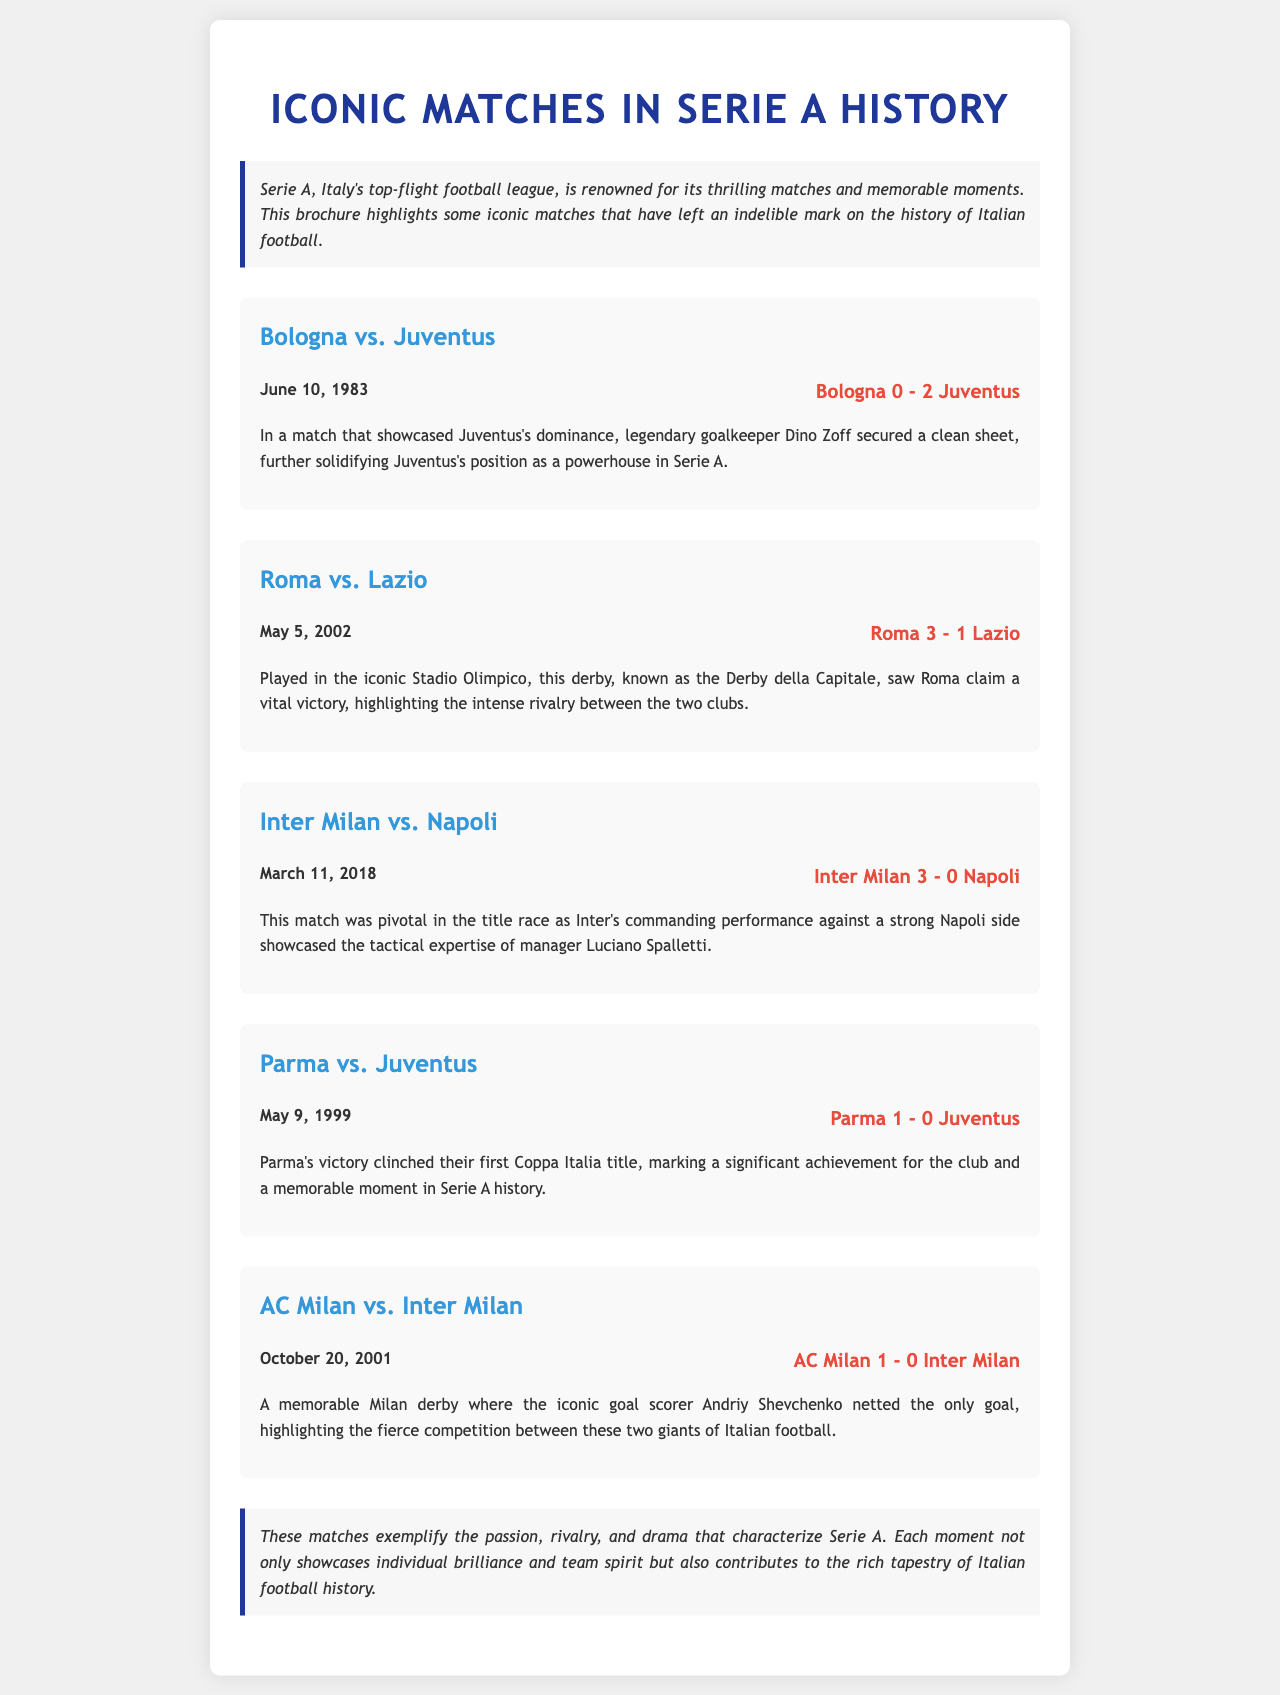What was the score of the Bologna vs. Juventus match? The score of the match is mentioned in the document as Bologna 0 - 2 Juventus.
Answer: Bologna 0 - 2 Juventus When did Roma play against Lazio? The date of the match is provided in the document as May 5, 2002.
Answer: May 5, 2002 Who was the goalkeeper for Juventus during the Bologna match? The document states that legendary goalkeeper Dino Zoff secured a clean sheet.
Answer: Dino Zoff What significant achievement did Parma secure in their match against Juventus? The document notes that Parma's victory clinched their first Coppa Italia title.
Answer: First Coppa Italia title Which team did Andriy Shevchenko score against in the Milan derby? According to the document, Andriy Shevchenko netted the only goal against Inter Milan.
Answer: Inter Milan What is the overall theme of the brochure? The brochure discusses iconic matches that characterize the passion, rivalry, and drama of Serie A.
Answer: Passion, rivalry, and drama What type of layout is used in the brochure? The layout of the brochure is structured with headings, match details, and visually separated sections for clarity.
Answer: Structured with headings and sections How many iconic matches are highlighted in the brochure? The document presents five iconic matches, as listed.
Answer: Five matches 